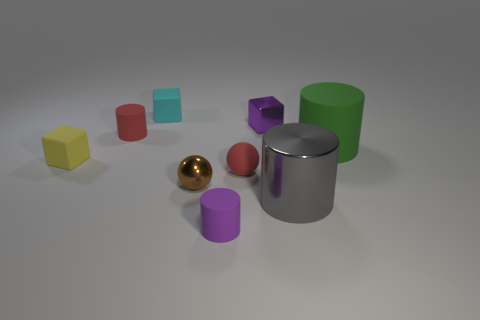Subtract 1 cylinders. How many cylinders are left? 3 Add 1 small purple metallic objects. How many objects exist? 10 Subtract all cubes. How many objects are left? 6 Subtract all small yellow cubes. Subtract all cyan rubber blocks. How many objects are left? 7 Add 7 tiny purple shiny objects. How many tiny purple shiny objects are left? 8 Add 6 yellow matte things. How many yellow matte things exist? 7 Subtract 0 blue cylinders. How many objects are left? 9 